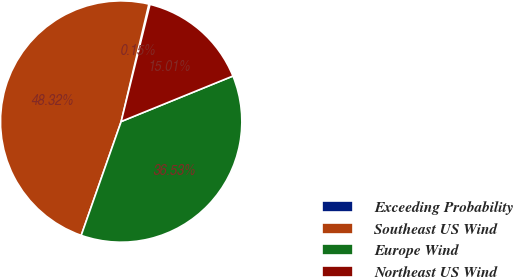Convert chart. <chart><loc_0><loc_0><loc_500><loc_500><pie_chart><fcel>Exceeding Probability<fcel>Southeast US Wind<fcel>Europe Wind<fcel>Northeast US Wind<nl><fcel>0.15%<fcel>48.32%<fcel>36.53%<fcel>15.01%<nl></chart> 